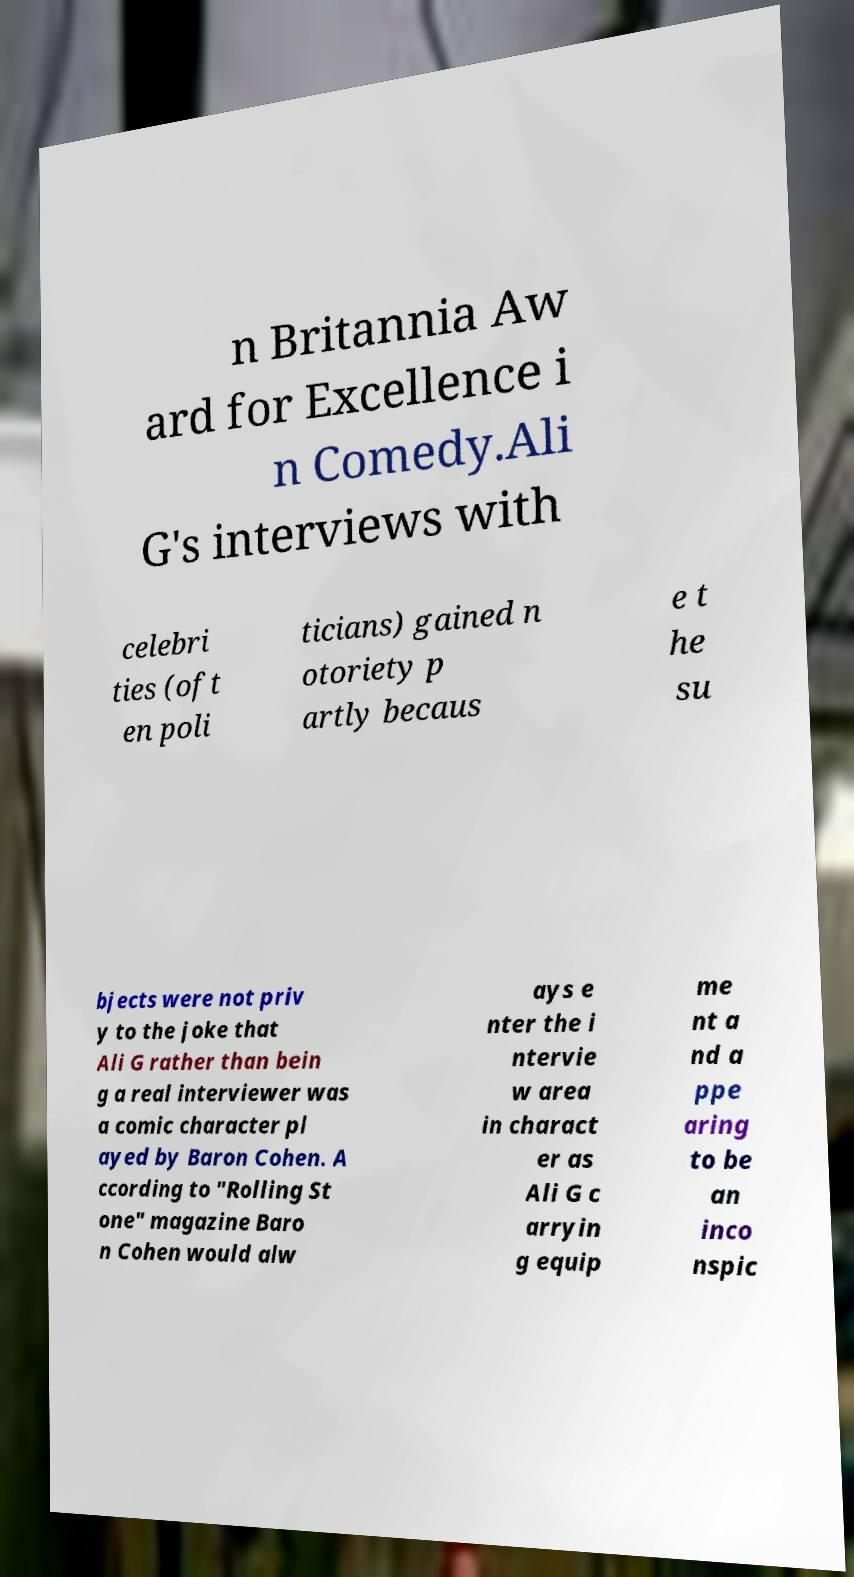Please identify and transcribe the text found in this image. n Britannia Aw ard for Excellence i n Comedy.Ali G's interviews with celebri ties (oft en poli ticians) gained n otoriety p artly becaus e t he su bjects were not priv y to the joke that Ali G rather than bein g a real interviewer was a comic character pl ayed by Baron Cohen. A ccording to "Rolling St one" magazine Baro n Cohen would alw ays e nter the i ntervie w area in charact er as Ali G c arryin g equip me nt a nd a ppe aring to be an inco nspic 